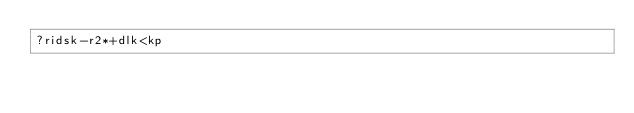Convert code to text. <code><loc_0><loc_0><loc_500><loc_500><_dc_>?ridsk-r2*+dlk<kp</code> 